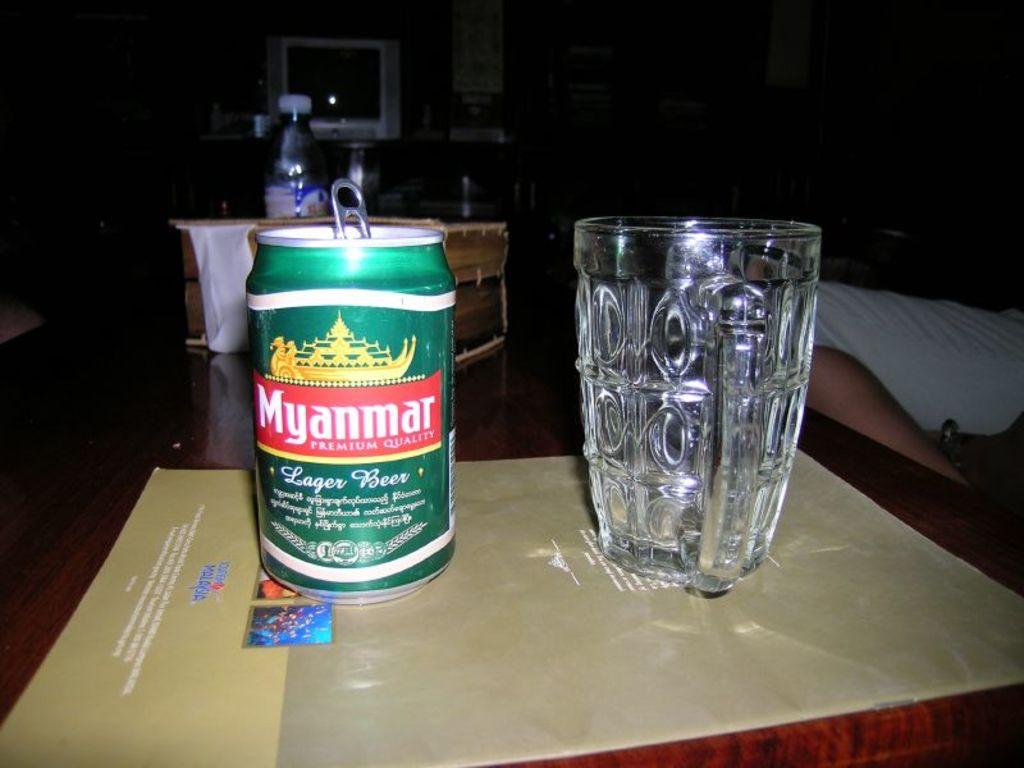<image>
Describe the image concisely. a Myanmar can of liquid and a glass next to it 